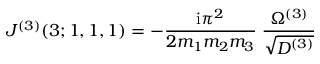Convert formula to latex. <formula><loc_0><loc_0><loc_500><loc_500>J ^ { ( 3 ) } ( 3 ; 1 , 1 , 1 ) = - \frac { i \pi ^ { 2 } } { 2 m _ { 1 } m _ { 2 } m _ { 3 } } \, \frac { \Omega ^ { ( 3 ) } } { \sqrt { D ^ { ( 3 ) } } }</formula> 